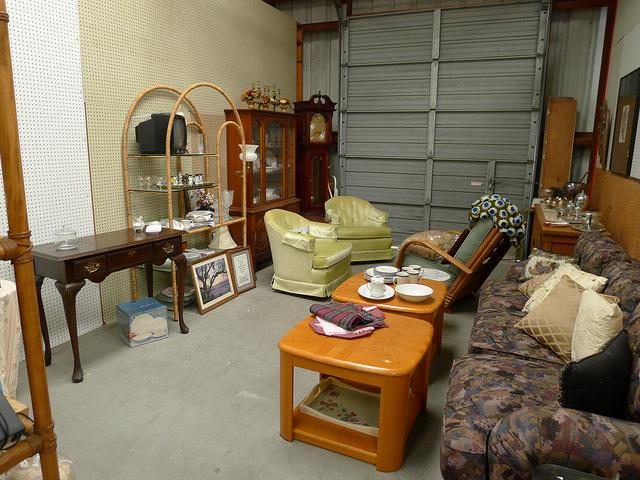Based on the door this furniture is most likely located in what? Please explain your reasoning. storage unit. The door is a storage unit. 